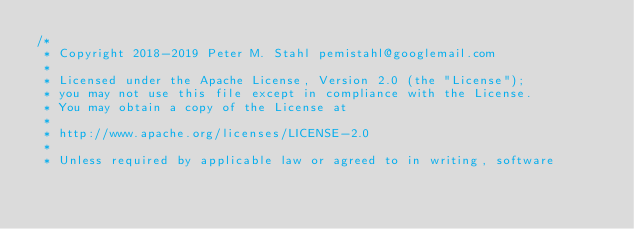<code> <loc_0><loc_0><loc_500><loc_500><_Kotlin_>/*
 * Copyright 2018-2019 Peter M. Stahl pemistahl@googlemail.com
 *
 * Licensed under the Apache License, Version 2.0 (the "License");
 * you may not use this file except in compliance with the License.
 * You may obtain a copy of the License at
 *
 * http://www.apache.org/licenses/LICENSE-2.0
 *
 * Unless required by applicable law or agreed to in writing, software</code> 